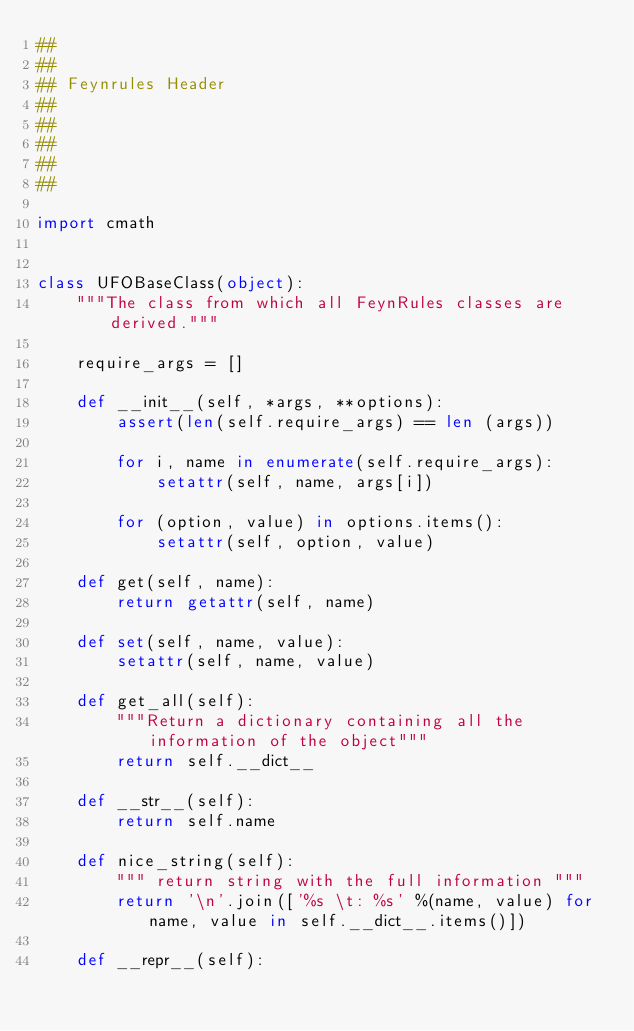Convert code to text. <code><loc_0><loc_0><loc_500><loc_500><_Python_>##
##
## Feynrules Header
##
##
##
##
##

import cmath


class UFOBaseClass(object):
    """The class from which all FeynRules classes are derived."""

    require_args = []

    def __init__(self, *args, **options):
        assert(len(self.require_args) == len (args))
    
        for i, name in enumerate(self.require_args):
            setattr(self, name, args[i])
    
        for (option, value) in options.items():
            setattr(self, option, value)

    def get(self, name):
        return getattr(self, name)
    
    def set(self, name, value):
        setattr(self, name, value)
        
    def get_all(self):
        """Return a dictionary containing all the information of the object"""
        return self.__dict__

    def __str__(self):
        return self.name

    def nice_string(self):
        """ return string with the full information """
        return '\n'.join(['%s \t: %s' %(name, value) for name, value in self.__dict__.items()])

    def __repr__(self):</code> 